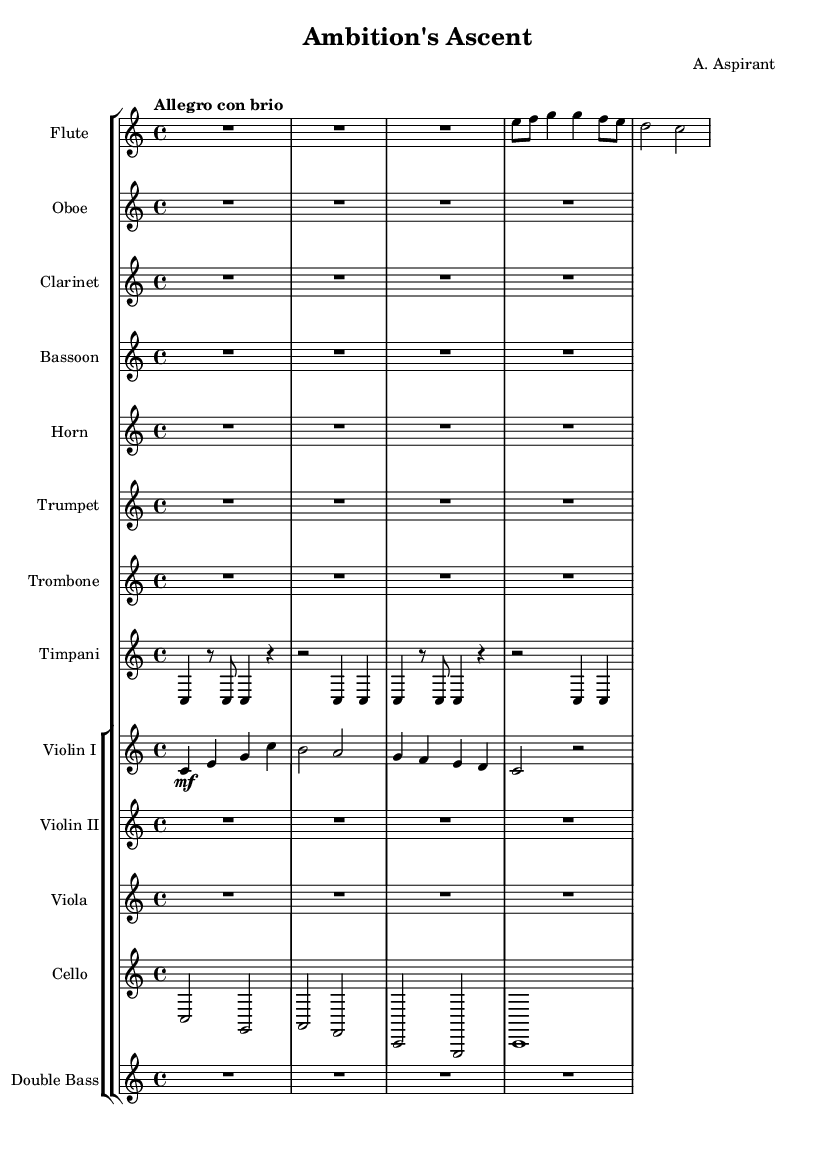What is the key signature of this music? The key signature is C major, which has no sharps or flats indicated in the staff.
Answer: C major What is the time signature of this music? The time signature is shown at the beginning of the score, displaying four beats per measure.
Answer: 4/4 What is the tempo marking for this piece? The tempo marking "Allegro con brio" indicates a lively and spirited pace, typical for a symphonic work.
Answer: Allegro con brio How many measures are there in the flute part? The flute part contains four measures, identified by the spaces between vertical bar lines.
Answer: 4 What is the highest note played by Violin I in the first phrase? The highest note is 'c', which is positioned at the top of the staff in the context of Violin I's part.
Answer: c In what section is the timpani part written? The timpani part is not only integral to the percussive section but is also written on the same staff as the other instruments, indicating cohesion.
Answer: Percussion Which instrument enters first in this composition? The flute is the first instrument to sound, as it plays the initial notes right after the introductory rest.
Answer: Flute 